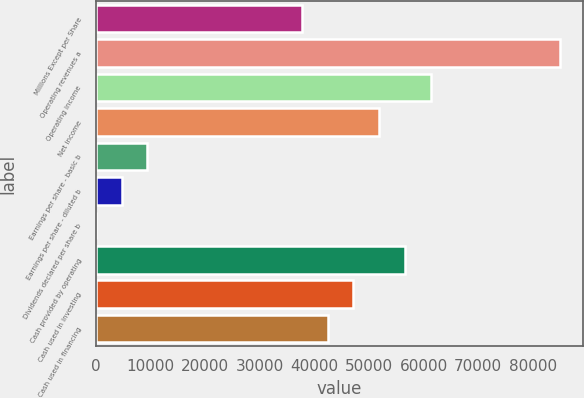<chart> <loc_0><loc_0><loc_500><loc_500><bar_chart><fcel>Millions Except per Share<fcel>Operating revenues a<fcel>Operating income<fcel>Net income<fcel>Earnings per share - basic b<fcel>Earnings per share - diluted b<fcel>Dividends declared per share b<fcel>Cash provided by operating<fcel>Cash used in investing<fcel>Cash used in financing<nl><fcel>37722.7<fcel>84874.5<fcel>61298.6<fcel>51868.2<fcel>9431.6<fcel>4716.43<fcel>1.25<fcel>56583.4<fcel>47153<fcel>42437.8<nl></chart> 